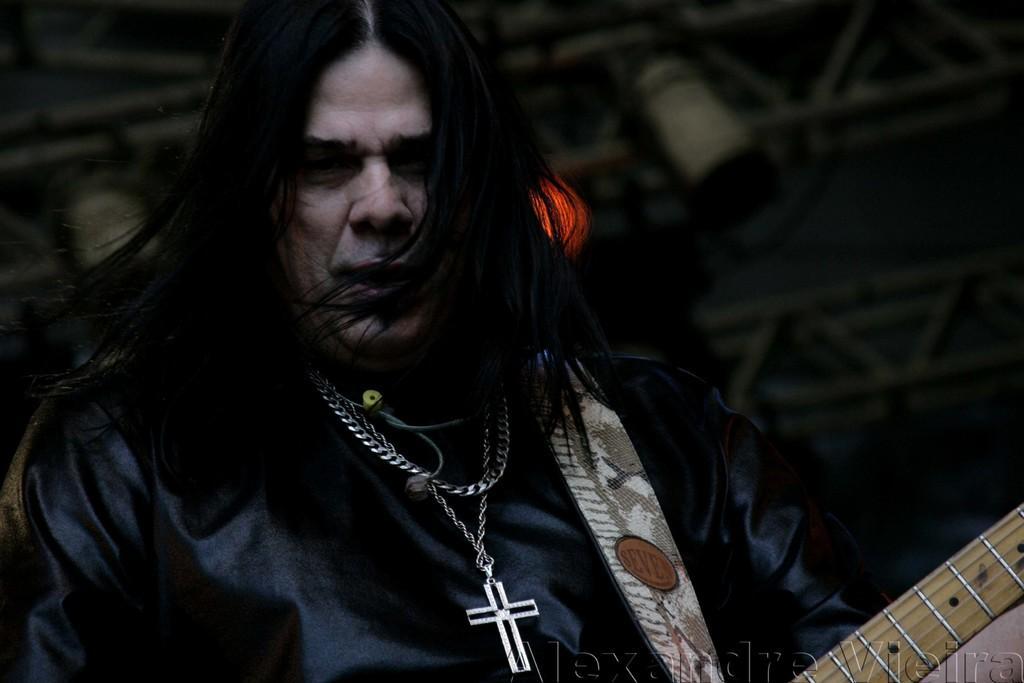In one or two sentences, can you explain what this image depicts? In this image I can see a person wearing black color jacket and holding a guitar in hands. This person is wearing some locket to the neck. 